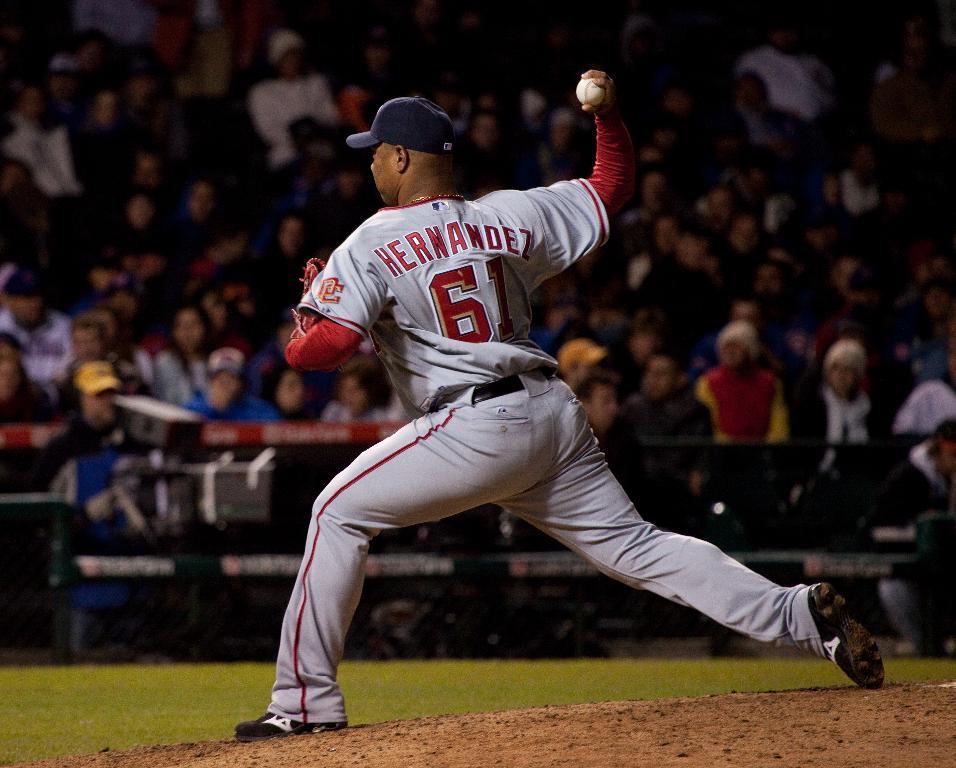What's the last name of number 61?
Make the answer very short. Hernandez. What 2 letters are printed on his sleve?
Ensure brevity in your answer.  Dc. 